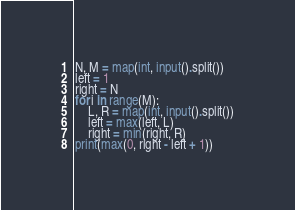Convert code to text. <code><loc_0><loc_0><loc_500><loc_500><_Python_>N, M = map(int, input().split())
left = 1
right = N
for i in range(M):
    L, R = map(int, input().split())
    left = max(left, L)
    right = min(right, R)
print(max(0, right - left + 1))
</code> 